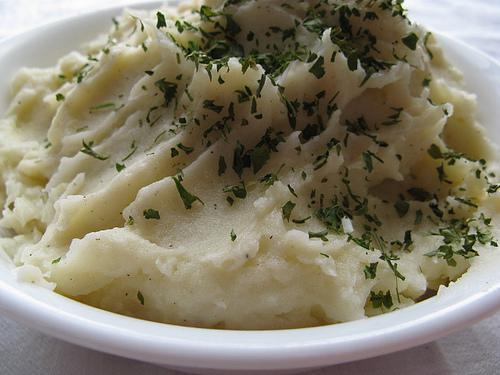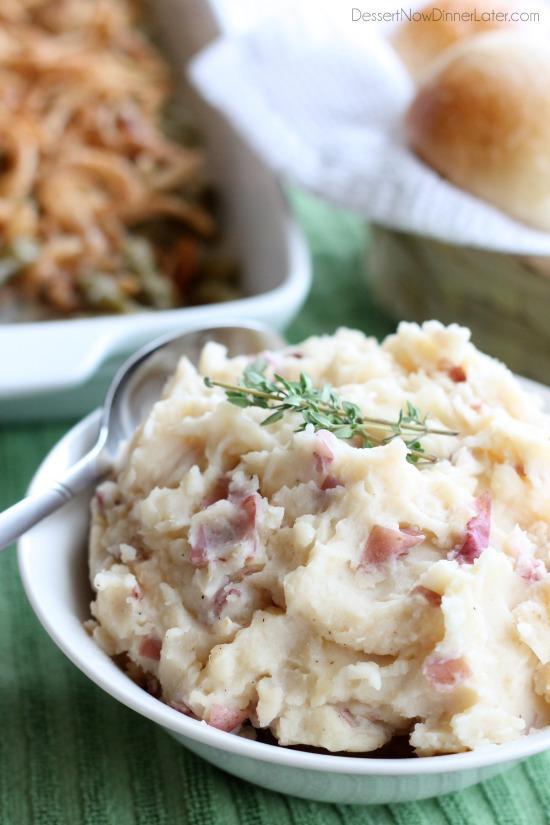The first image is the image on the left, the second image is the image on the right. Assess this claim about the two images: "Cloves of garlic are above one of the bowls of mashed potatoes.". Correct or not? Answer yes or no. No. The first image is the image on the left, the second image is the image on the right. Examine the images to the left and right. Is the description "The left image shows finely chopped green herbs sprinkled across the top of the mashed potatoes." accurate? Answer yes or no. Yes. 